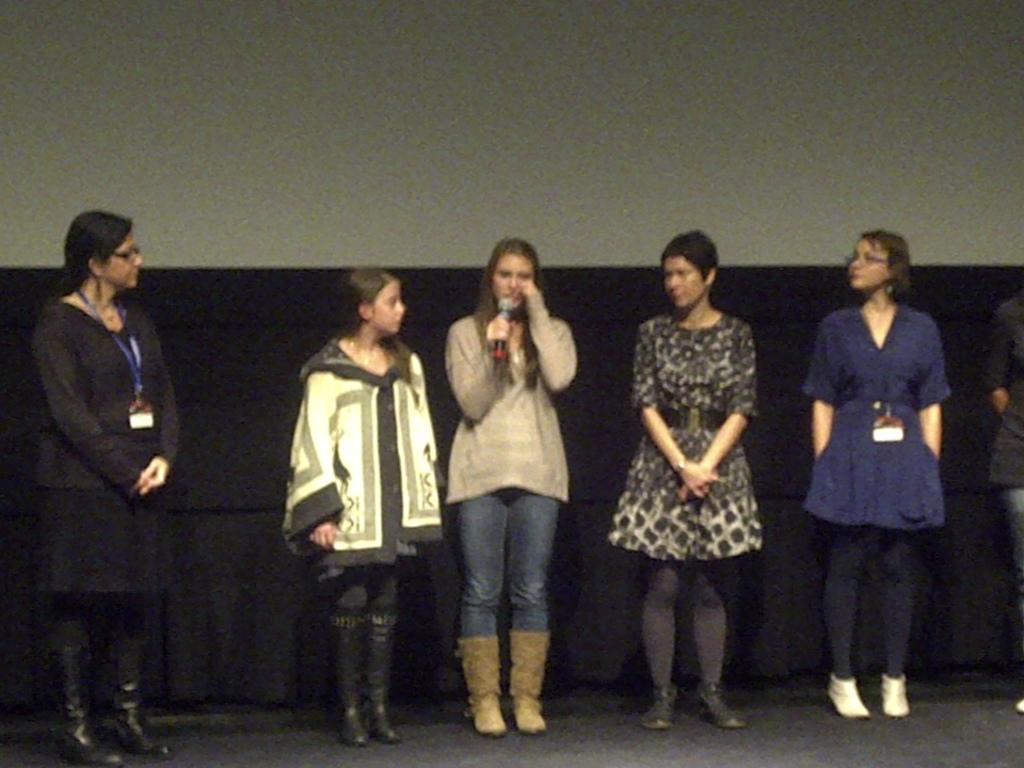How many people are present in the image? There are six persons in the image. What is one person doing in the image? One person is holding a microphone. What can be seen in the background of the image? There is a wall in the background of the image. What type of scale can be seen in the image? There is no scale present in the image. How many pigs are visible in the image? There are no pigs visible in the image. 